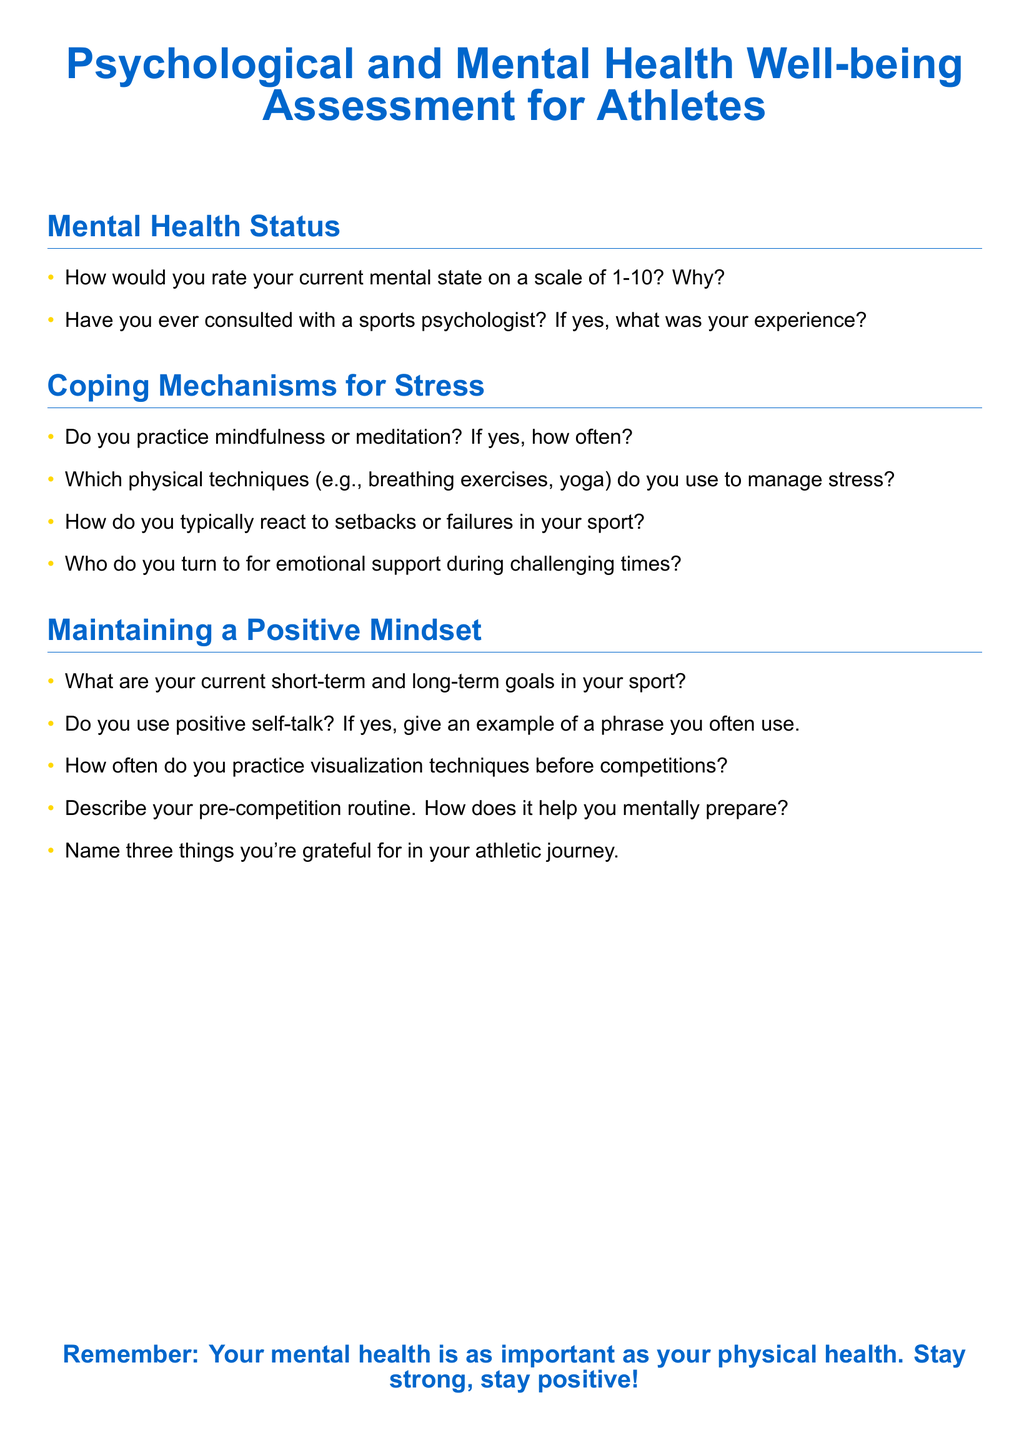What is the title of the document? The title of the document is the main heading presented at the top.
Answer: Psychological and Mental Health Well-being Assessment for Athletes How many sections are there in the document? The document has three main sections, which are clearly titled.
Answer: Three What color is used for the section headings? The color of the section headings is specified in the document's formatting.
Answer: Athlete blue What is one method mentioned for managing stress? The document lists various physical techniques as ways to manage stress.
Answer: Breathing exercises How often should visualization techniques be practiced before competitions? The document asks this as part of maintaining a positive mindset.
Answer: How often What are athletes encouraged to remember about their mental health? The closing statement reinforces the importance of mental health.
Answer: Your mental health is as important as your physical health 